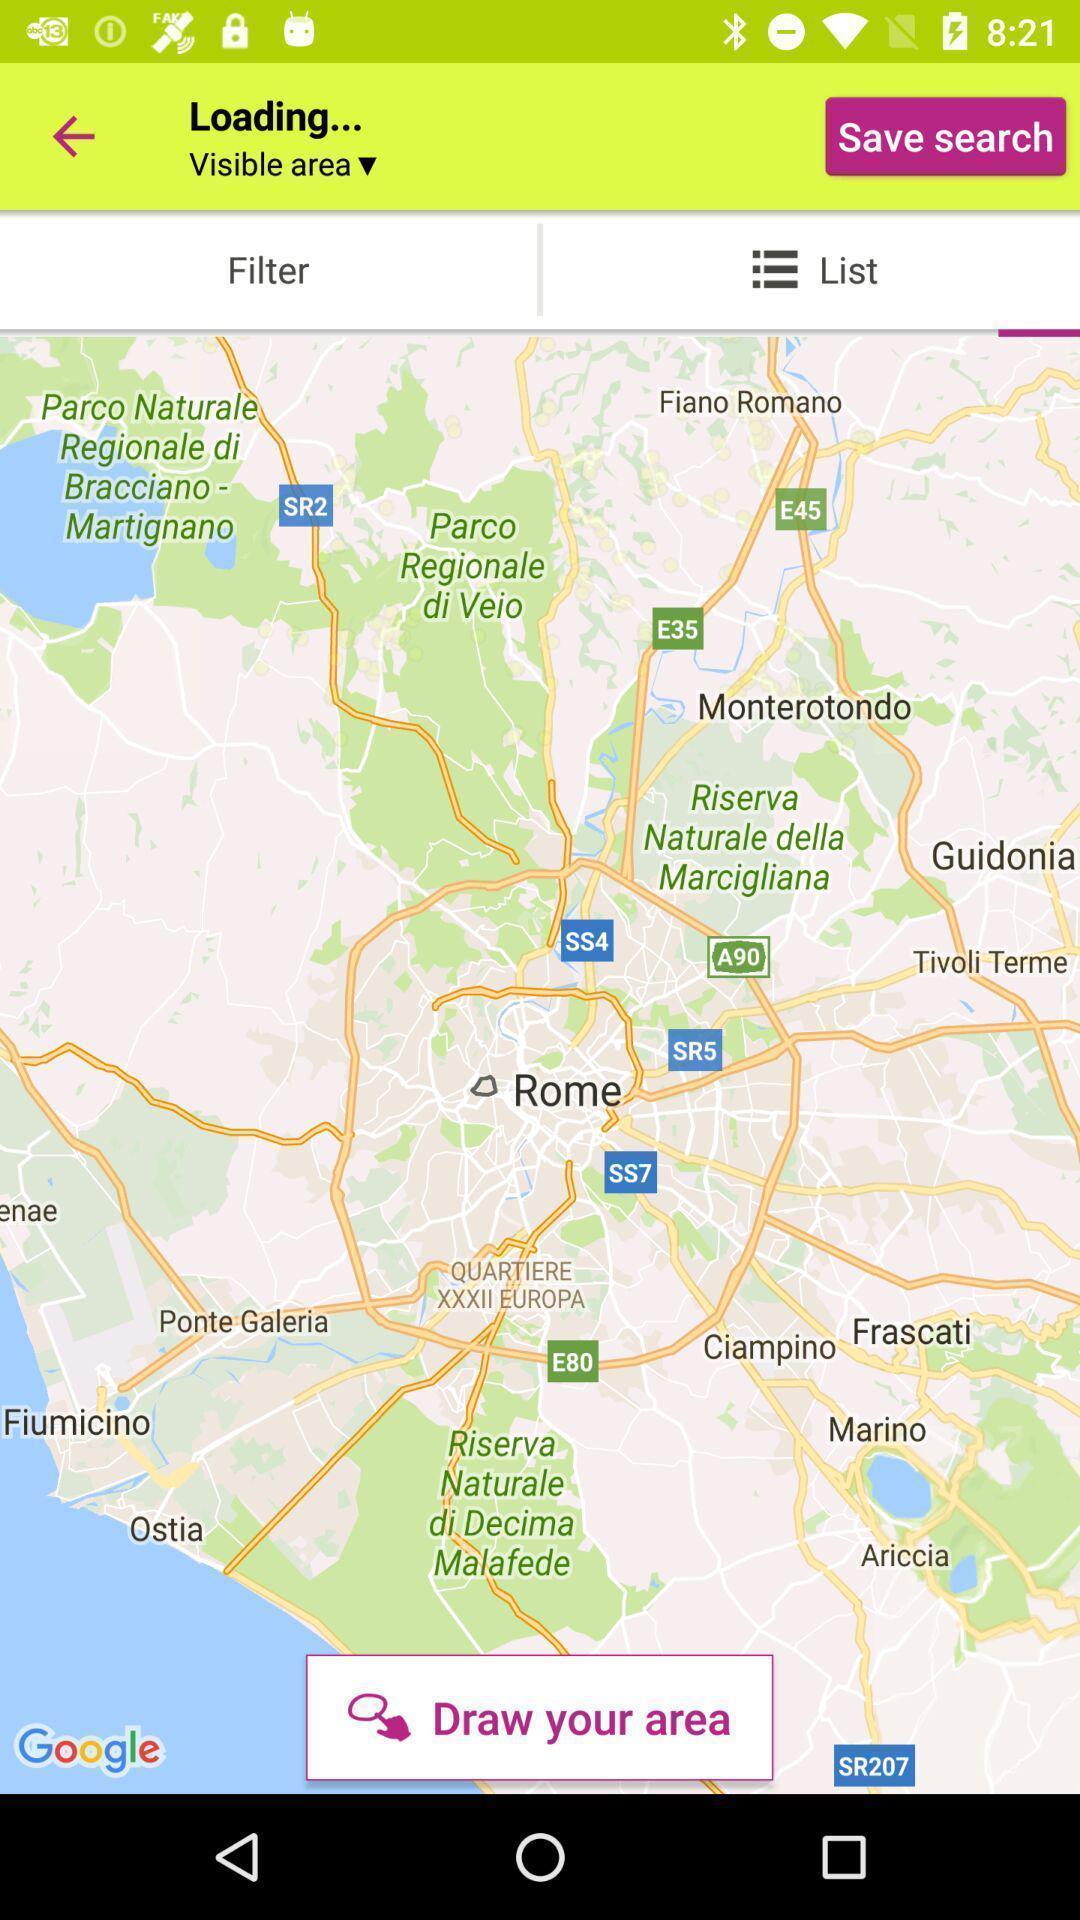What can you discern from this picture? Page that displaying gps application. 